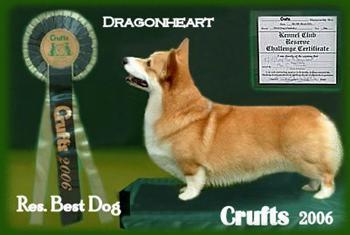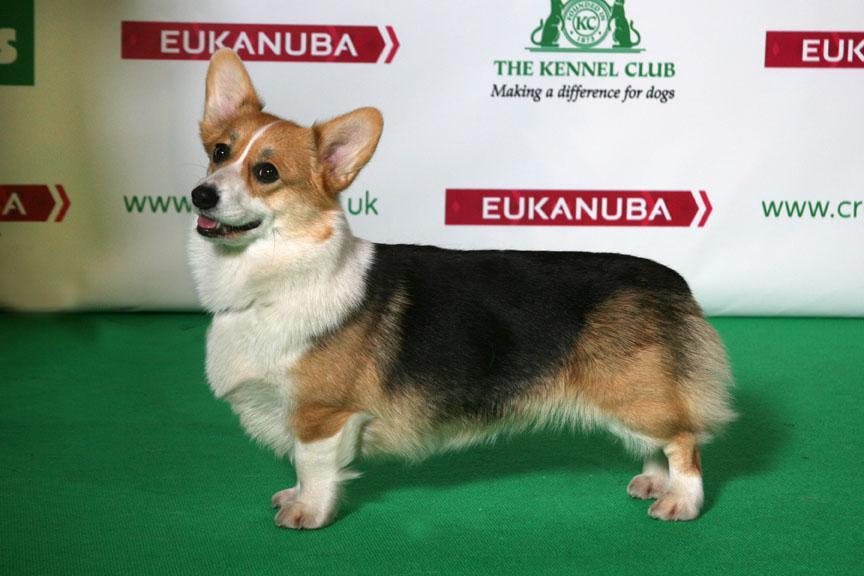The first image is the image on the left, the second image is the image on the right. For the images shown, is this caption "In one image, a prize ribbon is in front of a left-facing orange-and-white corgi standing on a green surface." true? Answer yes or no. Yes. The first image is the image on the left, the second image is the image on the right. Analyze the images presented: Is the assertion "The dog in one of the images is standing on a small step placed on the floor." valid? Answer yes or no. Yes. 